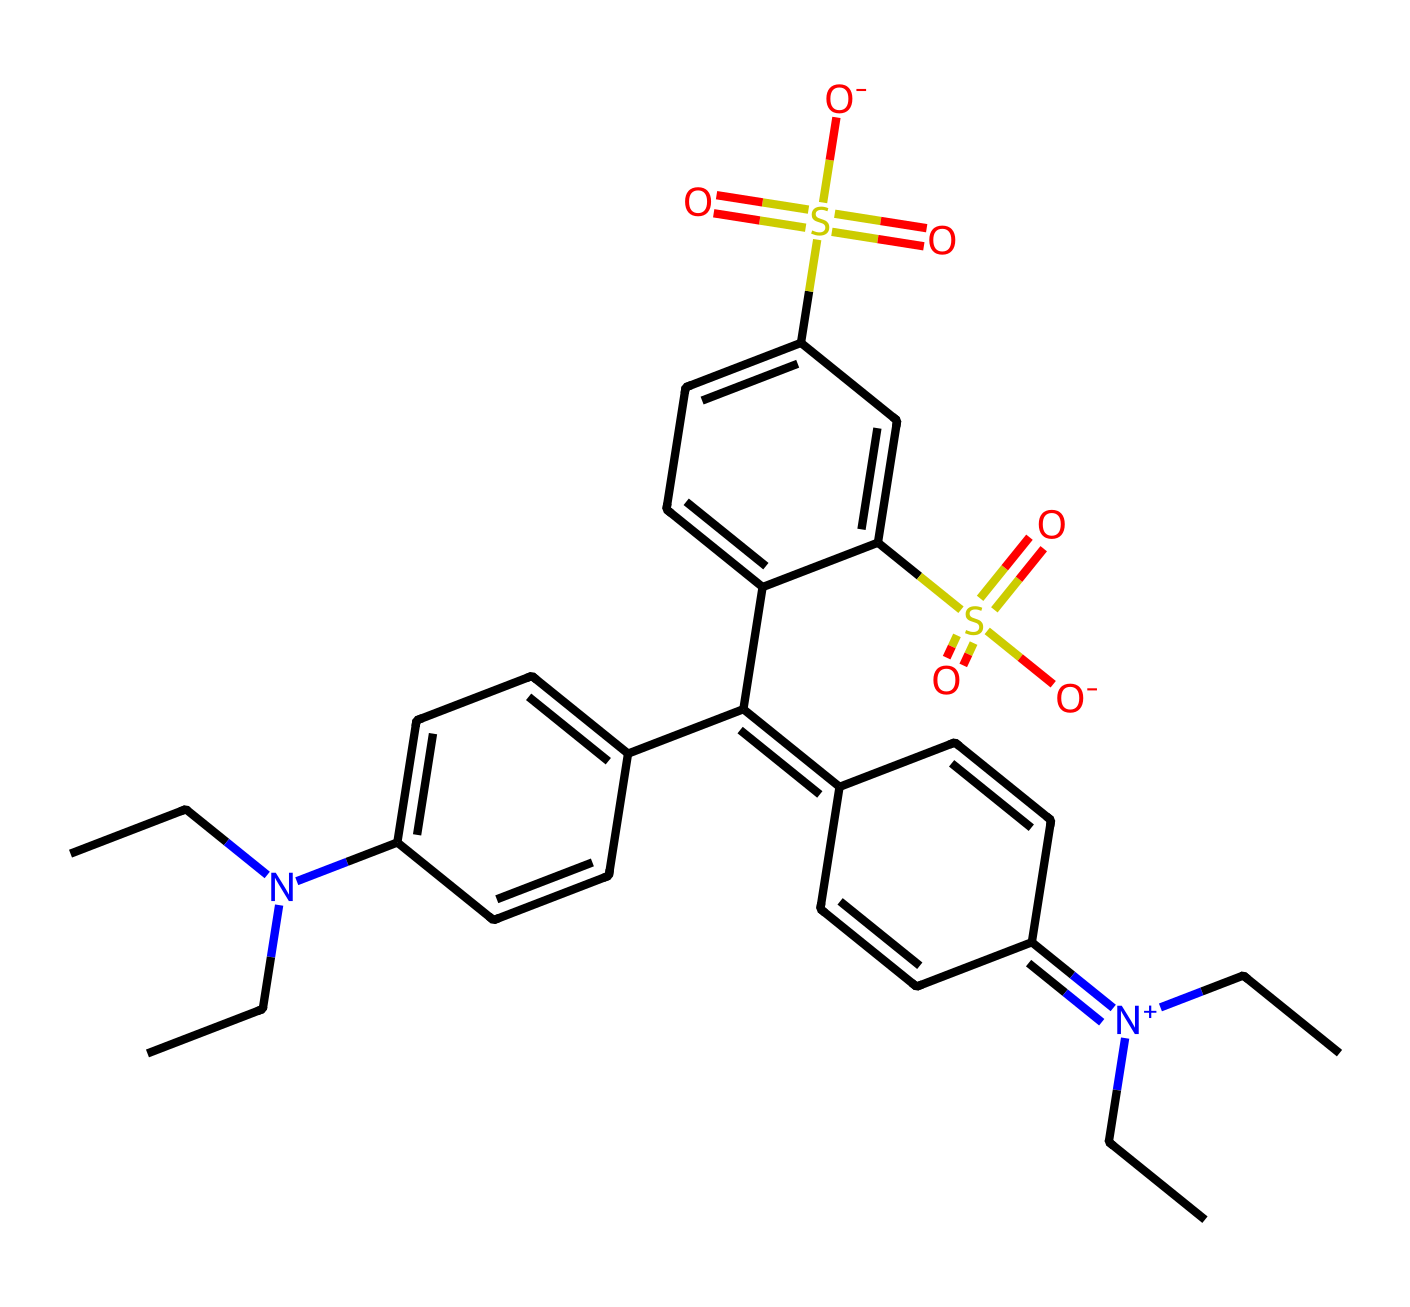what is the main functional group present in this chemical? The chemical contains sulfonic acid groups, identified by the presence of the sulfur atom bonded to oxygen atoms with a double bond and another oxygen with a negative charge (indicated by S(=O)(=O)[O-]). This structure confirms that the compound has distinct sulfonic acid functional groups.
Answer: sulfonic acid how many nitrogen atoms are present in this structure? By examining the structure, there are three nitrogen atoms indicated by 'N' in the SMILES representation, associated with different parts of the compound.
Answer: three what is the total number of carbon atoms in this chemical? Counting from the SMILES representation, the carbon atoms represented by 'C' include those in the aromatic rings and side chains, leading to a total of 23 carbon atoms in the entire structure.
Answer: twenty-three which component in the structure suggests that it is used as a food additive? The presence of the sulfonic acid groups is significant, as they enhance the solubility and stability of the colorant, thus making it suitable for use as a food additive in enhancing appearance.
Answer: sulfonic acid groups how many rings are present in this chemical structure? Analyzing the structure, there are two aromatic rings formed from the ring structures within the compound, revealing that there are a total of two rings.
Answer: two 